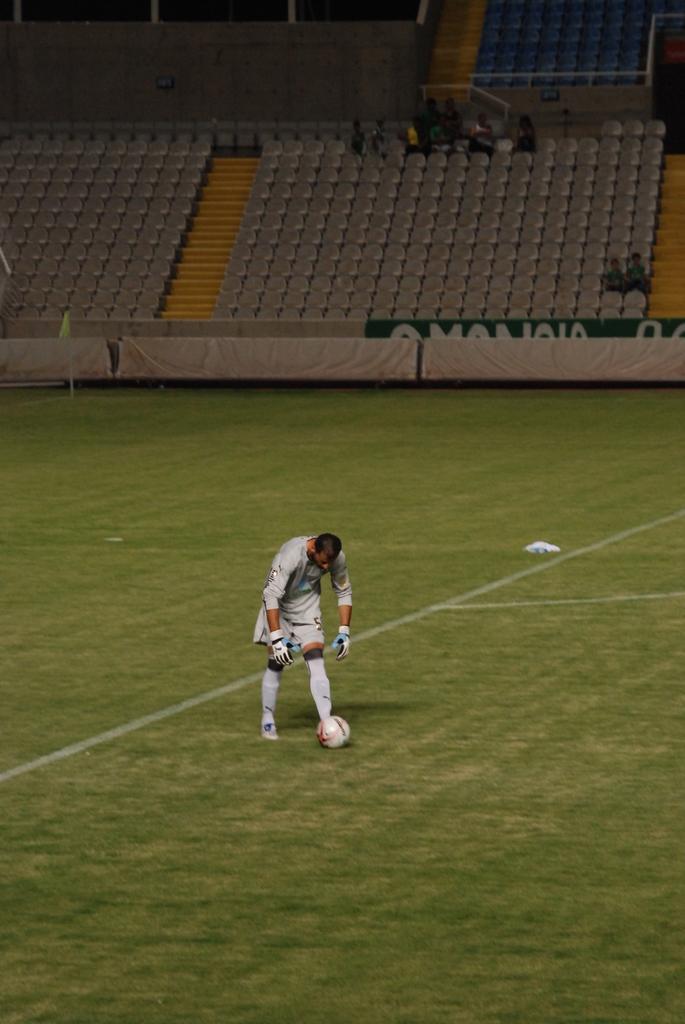Please provide a concise description of this image. In this picture we see a person is standing and on the grass there is a wall. Behind the person there are boards, chairs and a wall. 